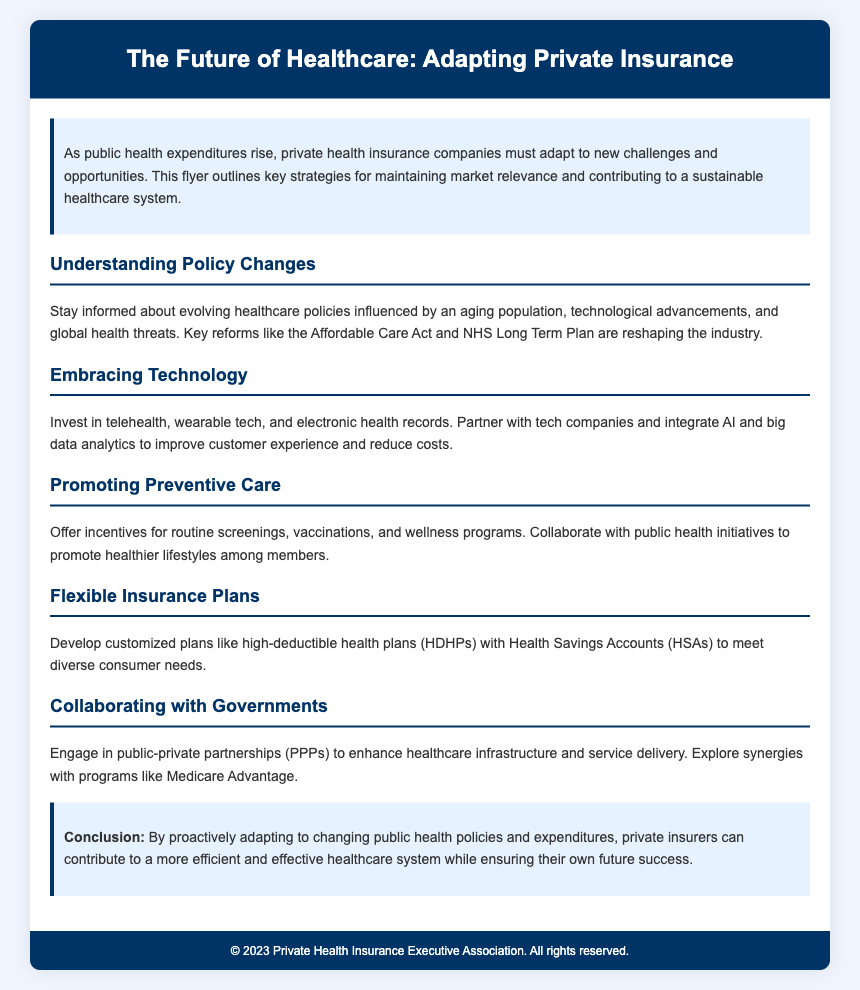what is the title of the document? The title is provided in the header section and describes the focus of the document.
Answer: The Future of Healthcare: Adapting Private Insurance what is one key strategy mentioned for private insurance to adapt? The document outlines various strategies, emphasizing the importance of technology adaptation among others.
Answer: Embracing Technology which healthcare policy reform is specifically mentioned? The document highlights key reforms influencing the healthcare landscape, particularly the Affordable Care Act.
Answer: Affordable Care Act what type of care does the document promote? The document advocates for certain health practices to improve member health and reduce costs.
Answer: Preventive Care what is a proposed feature of flexible insurance plans? The document details the offerings of customized plans, which cater to diverse consumer needs.
Answer: Health Savings Accounts (HSAs) 